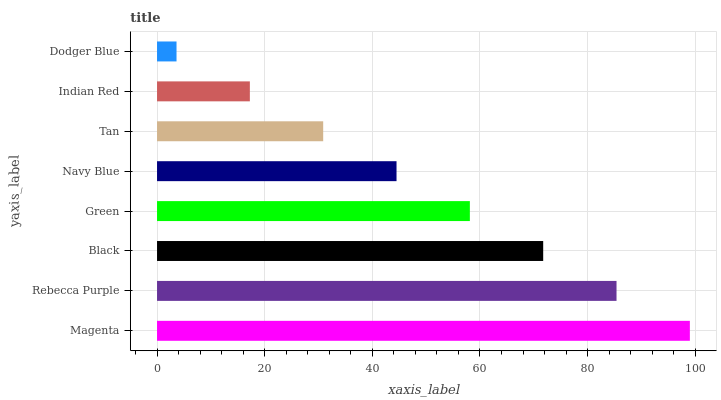Is Dodger Blue the minimum?
Answer yes or no. Yes. Is Magenta the maximum?
Answer yes or no. Yes. Is Rebecca Purple the minimum?
Answer yes or no. No. Is Rebecca Purple the maximum?
Answer yes or no. No. Is Magenta greater than Rebecca Purple?
Answer yes or no. Yes. Is Rebecca Purple less than Magenta?
Answer yes or no. Yes. Is Rebecca Purple greater than Magenta?
Answer yes or no. No. Is Magenta less than Rebecca Purple?
Answer yes or no. No. Is Green the high median?
Answer yes or no. Yes. Is Navy Blue the low median?
Answer yes or no. Yes. Is Indian Red the high median?
Answer yes or no. No. Is Green the low median?
Answer yes or no. No. 